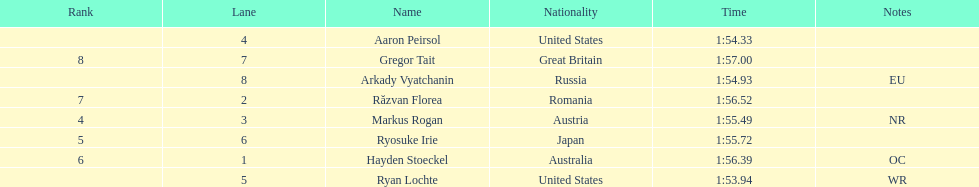Did austria or russia rank higher? Russia. 